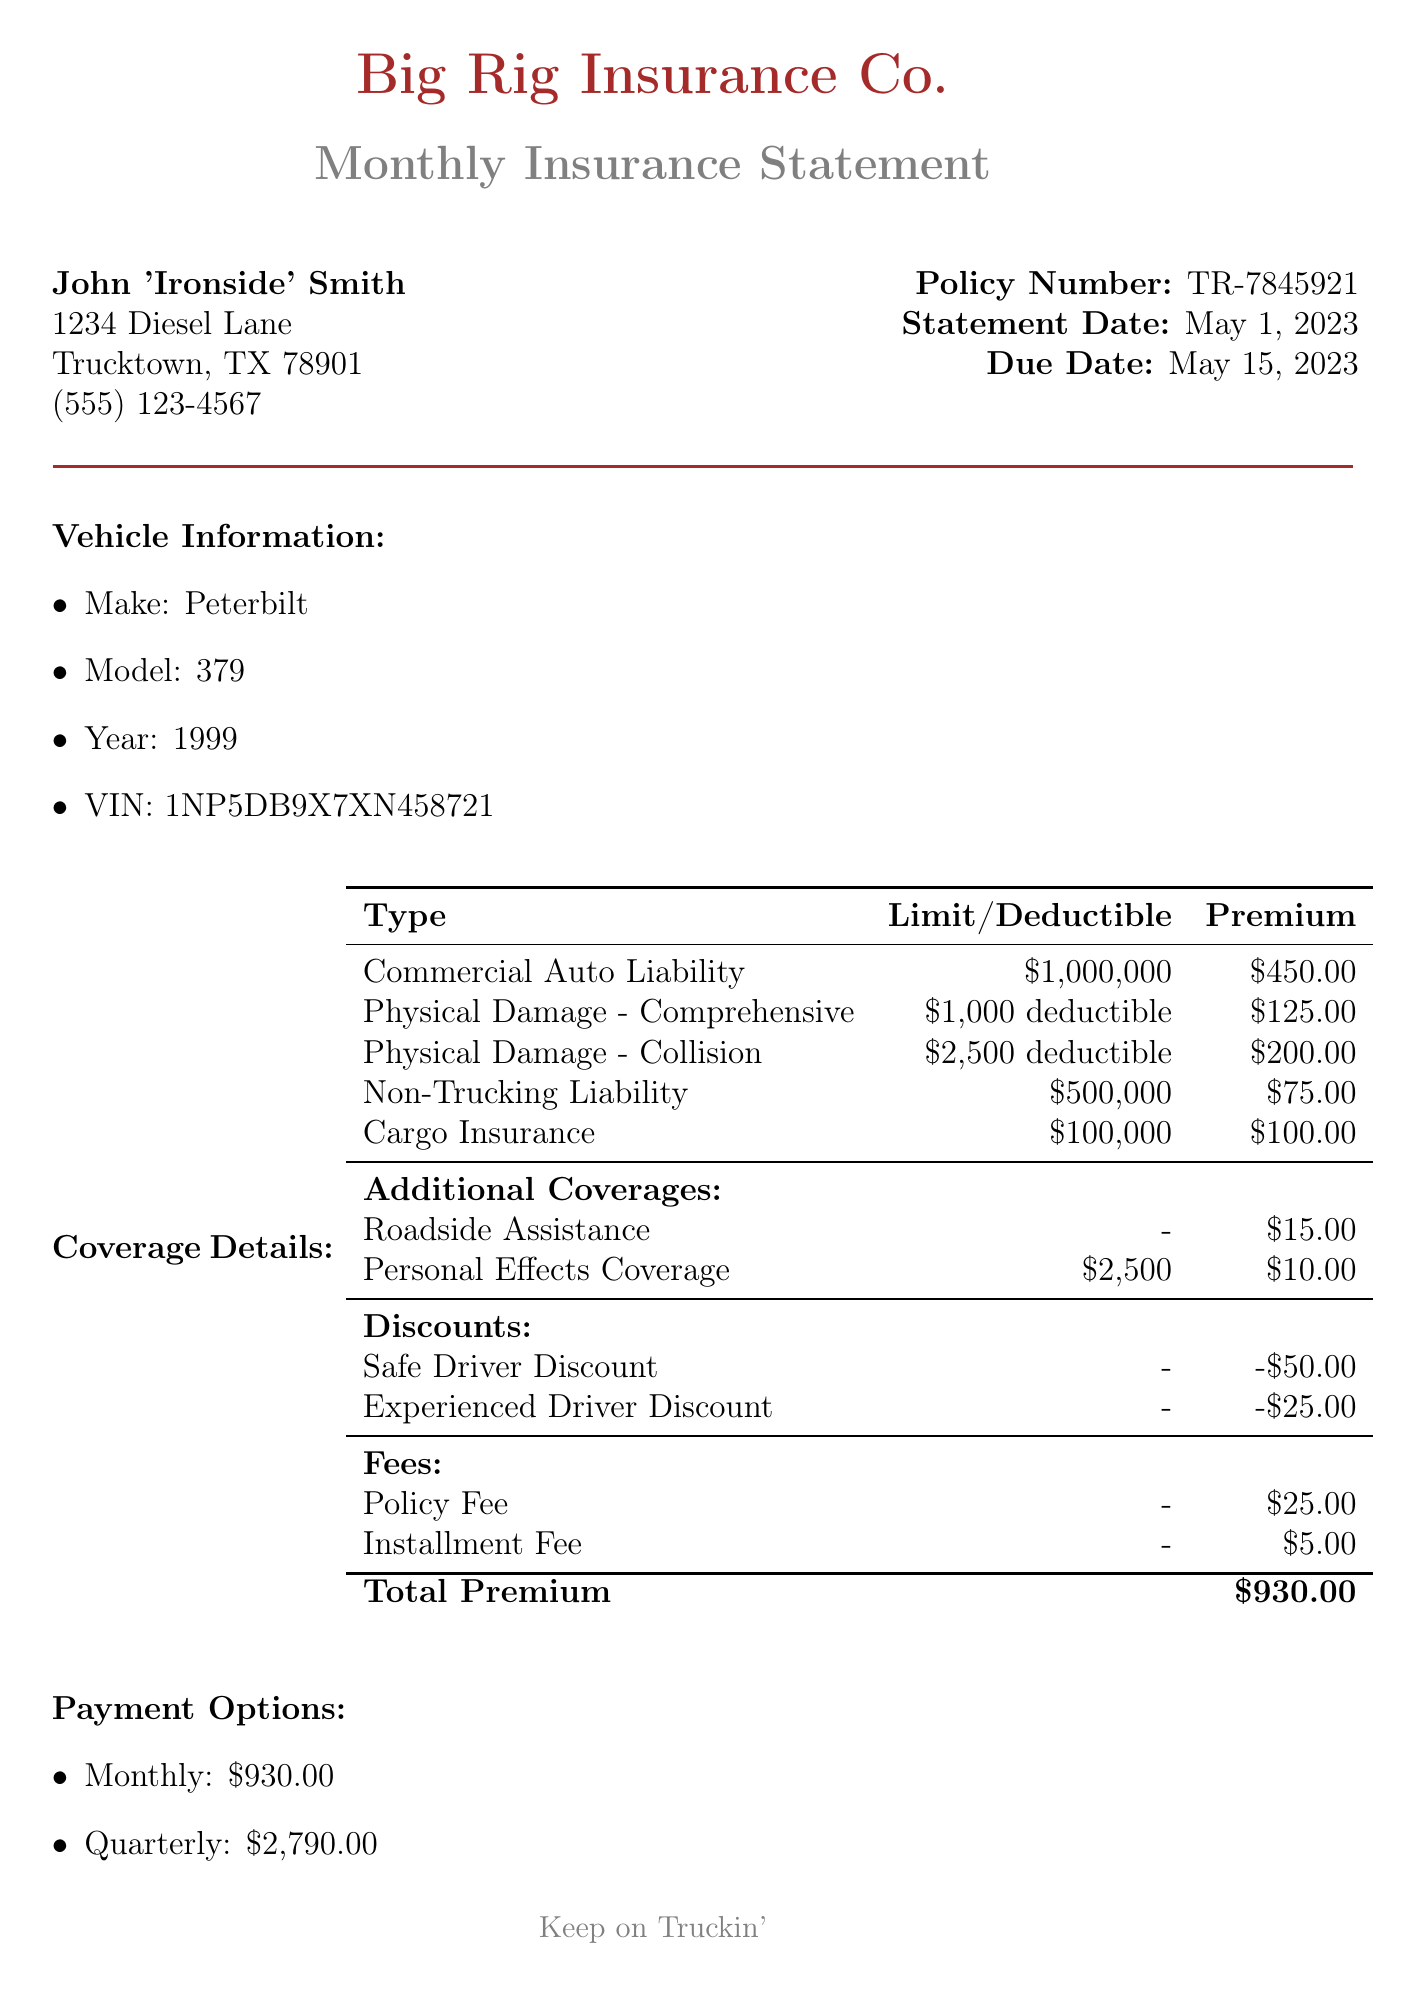What is the policy number? The policy number is explicitly stated near the top of the document, which is TR-7845921.
Answer: TR-7845921 What is the due date for the payment? The due date is mentioned in the document as May 15, 2023.
Answer: May 15, 2023 How much is the premium for Cargo Insurance? The premium for Cargo Insurance is given in the coverage details section as 100.00.
Answer: 100.00 What is the total premium amount? The total premium amount is highlighted at the end of the coverage details as 930.00.
Answer: 930.00 What deductions are listed in the discounts? The document lists two discounts: a Safe Driver Discount of 50.00 and an Experienced Driver Discount of 25.00.
Answer: Safe Driver Discount, Experienced Driver Discount What vehicle make and model are insured? The insured vehicle's make and model are provided as Peterbilt and 379 respectively.
Answer: Peterbilt, 379 What is one additional note mentioned? One of the additional notes mentioned concerns a premium increase due to an accident on I-40.
Answer: Premium increase due to recent accident on I-40 near Amarillo What type of insurance covers physical damage? Coverage for physical damage is specified in two types: Comprehensive and Collision.
Answer: Comprehensive, Collision What is one payment option available? One of the payment options listed is a monthly payment amount of 930.00.
Answer: Monthly: 930.00 